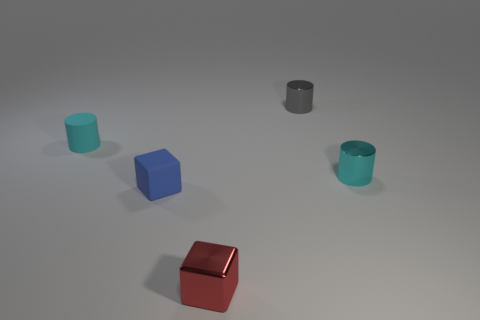How many objects are either small blue things or cyan cylinders on the right side of the blue matte block?
Provide a short and direct response. 2. Are there fewer purple objects than tiny red things?
Make the answer very short. Yes. What color is the object behind the cyan thing that is behind the small cyan shiny cylinder?
Offer a very short reply. Gray. What is the material of the other tiny object that is the same shape as the red thing?
Your answer should be compact. Rubber. How many rubber things are either brown balls or small cylinders?
Your answer should be very brief. 1. Is the cyan object that is behind the cyan shiny object made of the same material as the tiny gray thing that is left of the tiny cyan metal object?
Offer a terse response. No. Are there any small metallic cylinders?
Provide a short and direct response. Yes. There is a cyan thing that is on the left side of the small red object; is its shape the same as the object in front of the matte block?
Provide a succinct answer. No. Is there a big gray thing made of the same material as the tiny red thing?
Keep it short and to the point. No. Does the small cyan thing in front of the tiny rubber cylinder have the same material as the gray object?
Ensure brevity in your answer.  Yes. 